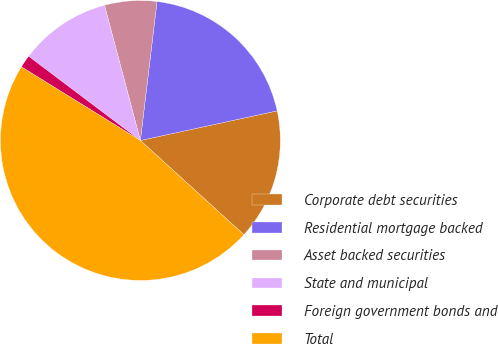Convert chart to OTSL. <chart><loc_0><loc_0><loc_500><loc_500><pie_chart><fcel>Corporate debt securities<fcel>Residential mortgage backed<fcel>Asset backed securities<fcel>State and municipal<fcel>Foreign government bonds and<fcel>Total<nl><fcel>15.15%<fcel>19.71%<fcel>6.03%<fcel>10.59%<fcel>1.46%<fcel>47.07%<nl></chart> 